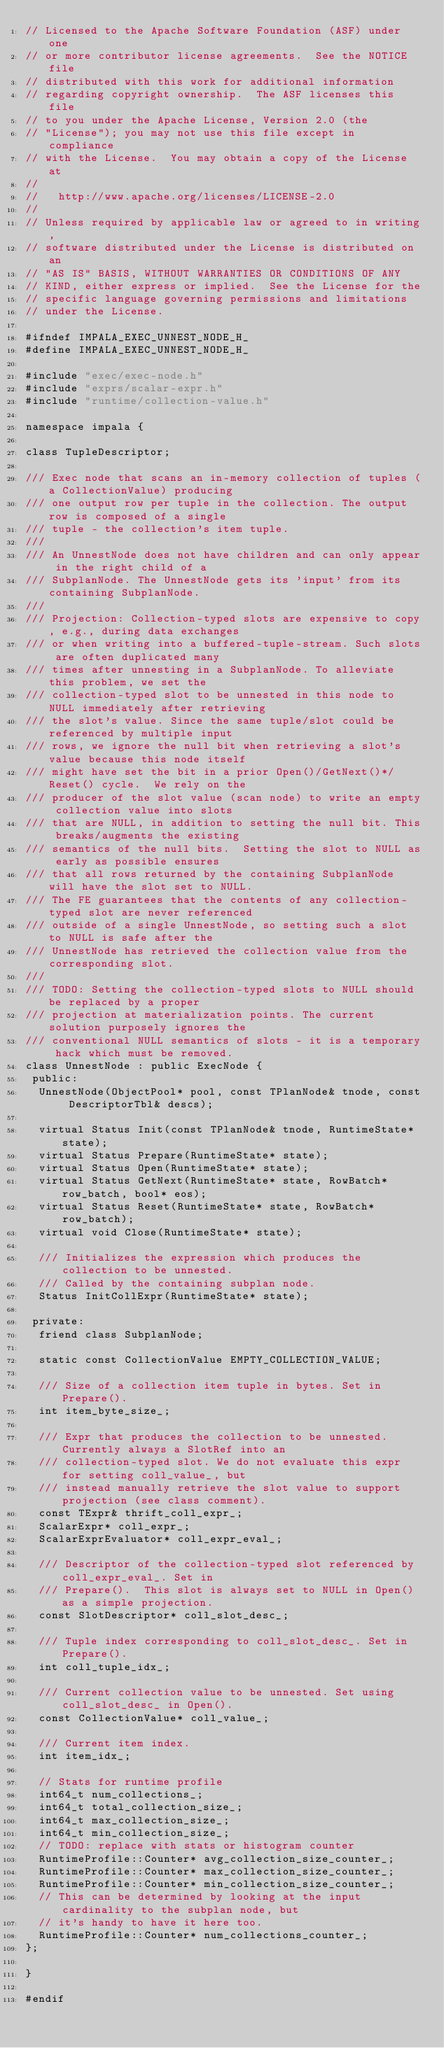<code> <loc_0><loc_0><loc_500><loc_500><_C_>// Licensed to the Apache Software Foundation (ASF) under one
// or more contributor license agreements.  See the NOTICE file
// distributed with this work for additional information
// regarding copyright ownership.  The ASF licenses this file
// to you under the Apache License, Version 2.0 (the
// "License"); you may not use this file except in compliance
// with the License.  You may obtain a copy of the License at
//
//   http://www.apache.org/licenses/LICENSE-2.0
//
// Unless required by applicable law or agreed to in writing,
// software distributed under the License is distributed on an
// "AS IS" BASIS, WITHOUT WARRANTIES OR CONDITIONS OF ANY
// KIND, either express or implied.  See the License for the
// specific language governing permissions and limitations
// under the License.

#ifndef IMPALA_EXEC_UNNEST_NODE_H_
#define IMPALA_EXEC_UNNEST_NODE_H_

#include "exec/exec-node.h"
#include "exprs/scalar-expr.h"
#include "runtime/collection-value.h"

namespace impala {

class TupleDescriptor;

/// Exec node that scans an in-memory collection of tuples (a CollectionValue) producing
/// one output row per tuple in the collection. The output row is composed of a single
/// tuple - the collection's item tuple.
///
/// An UnnestNode does not have children and can only appear in the right child of a
/// SubplanNode. The UnnestNode gets its 'input' from its containing SubplanNode.
///
/// Projection: Collection-typed slots are expensive to copy, e.g., during data exchanges
/// or when writing into a buffered-tuple-stream. Such slots are often duplicated many
/// times after unnesting in a SubplanNode. To alleviate this problem, we set the
/// collection-typed slot to be unnested in this node to NULL immediately after retrieving
/// the slot's value. Since the same tuple/slot could be referenced by multiple input
/// rows, we ignore the null bit when retrieving a slot's value because this node itself
/// might have set the bit in a prior Open()/GetNext()*/Reset() cycle.  We rely on the
/// producer of the slot value (scan node) to write an empty collection value into slots
/// that are NULL, in addition to setting the null bit. This breaks/augments the existing
/// semantics of the null bits.  Setting the slot to NULL as early as possible ensures
/// that all rows returned by the containing SubplanNode will have the slot set to NULL.
/// The FE guarantees that the contents of any collection-typed slot are never referenced
/// outside of a single UnnestNode, so setting such a slot to NULL is safe after the
/// UnnestNode has retrieved the collection value from the corresponding slot.
///
/// TODO: Setting the collection-typed slots to NULL should be replaced by a proper
/// projection at materialization points. The current solution purposely ignores the
/// conventional NULL semantics of slots - it is a temporary hack which must be removed.
class UnnestNode : public ExecNode {
 public:
  UnnestNode(ObjectPool* pool, const TPlanNode& tnode, const DescriptorTbl& descs);

  virtual Status Init(const TPlanNode& tnode, RuntimeState* state);
  virtual Status Prepare(RuntimeState* state);
  virtual Status Open(RuntimeState* state);
  virtual Status GetNext(RuntimeState* state, RowBatch* row_batch, bool* eos);
  virtual Status Reset(RuntimeState* state, RowBatch* row_batch);
  virtual void Close(RuntimeState* state);

  /// Initializes the expression which produces the collection to be unnested.
  /// Called by the containing subplan node.
  Status InitCollExpr(RuntimeState* state);

 private:
  friend class SubplanNode;

  static const CollectionValue EMPTY_COLLECTION_VALUE;

  /// Size of a collection item tuple in bytes. Set in Prepare().
  int item_byte_size_;

  /// Expr that produces the collection to be unnested. Currently always a SlotRef into an
  /// collection-typed slot. We do not evaluate this expr for setting coll_value_, but
  /// instead manually retrieve the slot value to support projection (see class comment).
  const TExpr& thrift_coll_expr_;
  ScalarExpr* coll_expr_;
  ScalarExprEvaluator* coll_expr_eval_;

  /// Descriptor of the collection-typed slot referenced by coll_expr_eval_. Set in
  /// Prepare().  This slot is always set to NULL in Open() as a simple projection.
  const SlotDescriptor* coll_slot_desc_;

  /// Tuple index corresponding to coll_slot_desc_. Set in Prepare().
  int coll_tuple_idx_;

  /// Current collection value to be unnested. Set using coll_slot_desc_ in Open().
  const CollectionValue* coll_value_;

  /// Current item index.
  int item_idx_;

  // Stats for runtime profile
  int64_t num_collections_;
  int64_t total_collection_size_;
  int64_t max_collection_size_;
  int64_t min_collection_size_;
  // TODO: replace with stats or histogram counter
  RuntimeProfile::Counter* avg_collection_size_counter_;
  RuntimeProfile::Counter* max_collection_size_counter_;
  RuntimeProfile::Counter* min_collection_size_counter_;
  // This can be determined by looking at the input cardinality to the subplan node, but
  // it's handy to have it here too.
  RuntimeProfile::Counter* num_collections_counter_;
};

}

#endif
</code> 